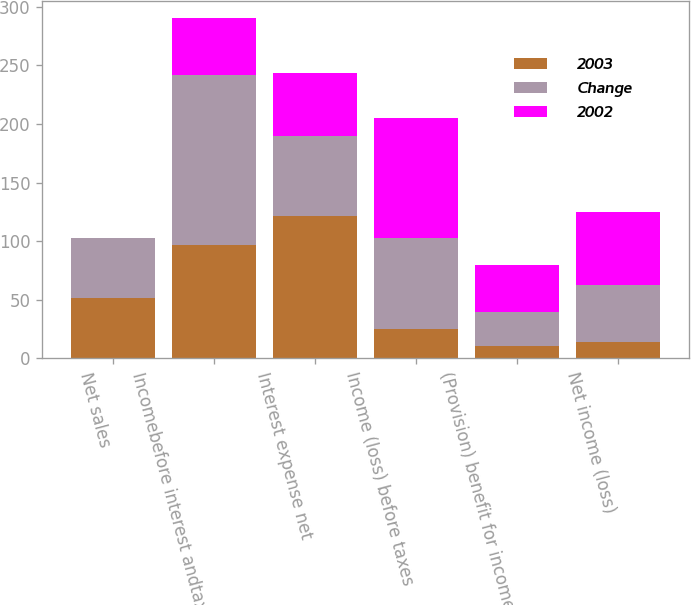<chart> <loc_0><loc_0><loc_500><loc_500><stacked_bar_chart><ecel><fcel>Net sales<fcel>Incomebefore interest andtaxes<fcel>Interest expense net<fcel>Income (loss) before taxes<fcel>(Provision) benefit for income<fcel>Net income (loss)<nl><fcel>2003<fcel>51.25<fcel>96.9<fcel>121.8<fcel>24.9<fcel>10.5<fcel>14.4<nl><fcel>Change<fcel>51.25<fcel>145.3<fcel>67.7<fcel>77.6<fcel>29.4<fcel>48.2<nl><fcel>2002<fcel>0.4<fcel>48.4<fcel>54.1<fcel>102.5<fcel>39.9<fcel>62.6<nl></chart> 